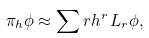<formula> <loc_0><loc_0><loc_500><loc_500>\pi _ { h } \phi \approx \sum r h ^ { r } \, L _ { r } \phi ,</formula> 